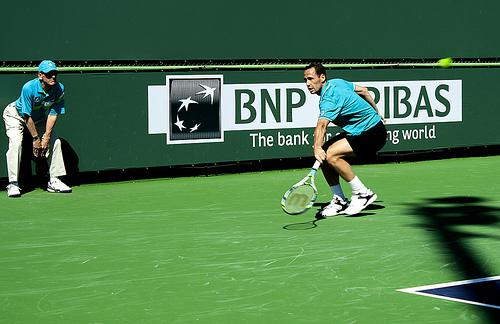Question: what brand is the tennis racket?
Choices:
A. Addidas.
B. Nike.
C. Wilson.
D. Penn.
Answer with the letter. Answer: C Question: what color is the tennis players shirt?
Choices:
A. Purple.
B. Yellow.
C. Black.
D. Teal.
Answer with the letter. Answer: D Question: where is the tennis ball in the picture?
Choices:
A. Top right corner.
B. Top left corner.
C. Bottom right corner.
D. Bottom left corner.
Answer with the letter. Answer: A Question: what sport is being played in the picture?
Choices:
A. Soccer.
B. Tennis.
C. Basketball.
D. Baseball.
Answer with the letter. Answer: B Question: how many people are wearing a hat in the picture?
Choices:
A. Two.
B. Zero.
C. Three.
D. One.
Answer with the letter. Answer: D 